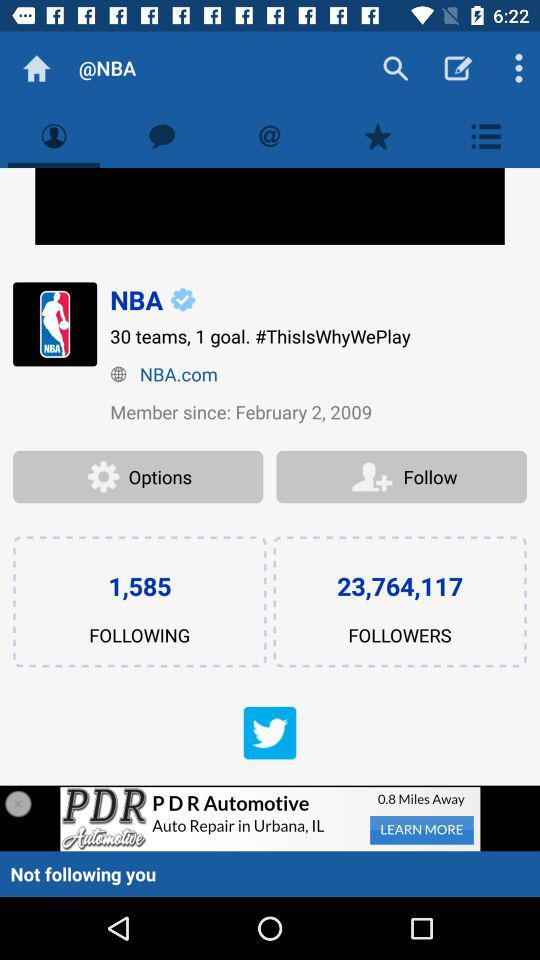How many teams are there in the NBA? There are 30 teams. 